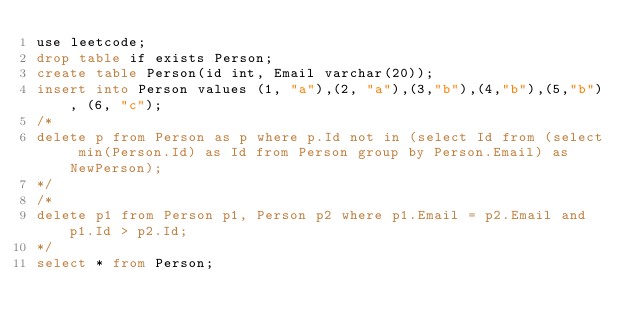<code> <loc_0><loc_0><loc_500><loc_500><_SQL_>use leetcode;
drop table if exists Person;
create table Person(id int, Email varchar(20));
insert into Person values (1, "a"),(2, "a"),(3,"b"),(4,"b"),(5,"b"), (6, "c");
/*
delete p from Person as p where p.Id not in (select Id from (select min(Person.Id) as Id from Person group by Person.Email) as NewPerson);
*/
/*
delete p1 from Person p1, Person p2 where p1.Email = p2.Email and p1.Id > p2.Id;
*/
select * from Person;
</code> 